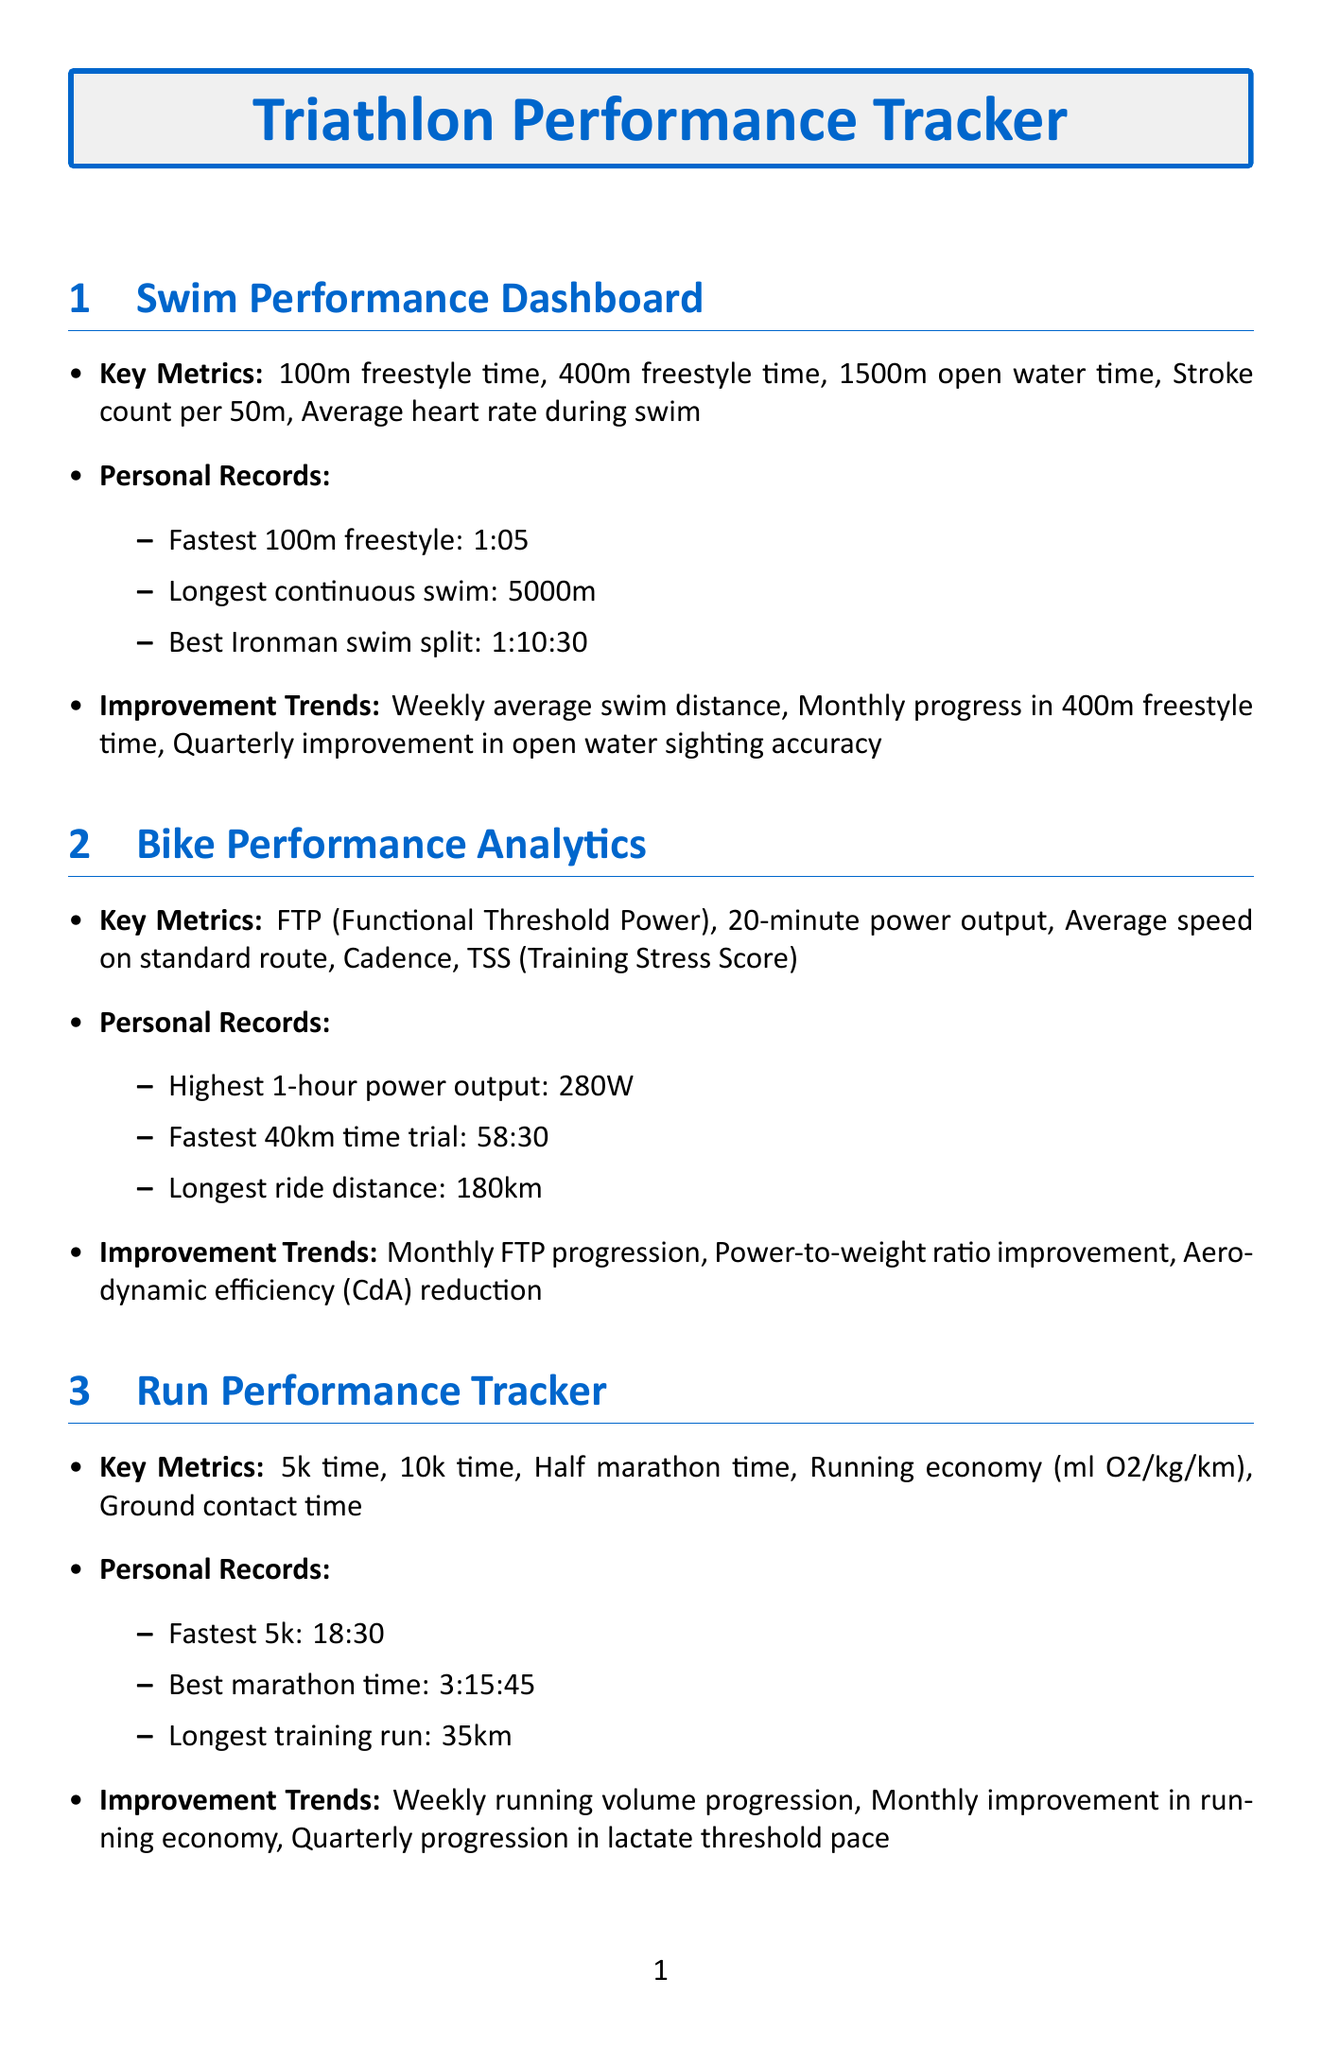what are the key metrics for swim performance? The document lists the swim performance metrics, including 100m freestyle time, 400m freestyle time, 1500m open water time, stroke count per 50m, and average heart rate during swim.
Answer: 100m freestyle time, 400m freestyle time, 1500m open water time, stroke count per 50m, average heart rate during swim what is the fastest 5k time? The personal records section for the run performance tracker states the fastest 5k time is 18:30.
Answer: 18:30 which device tracks heart rate monitoring? The document indicates the Garmin Forerunner 945 tracks heart rate monitoring among other metrics.
Answer: Garmin Forerunner 945 how often should long-term trend analysis be reviewed? According to the progress review frequency, long-term trend analysis should be reviewed quarterly.
Answer: Quarterly what is the best Ironman swim split recorded? The document notes the best Ironman swim split as 1:10:30 in the personal records for swim performance.
Answer: 1:10:30 which metric shows monthly FTP progression? The improvement trends for bike performance analytics include the metric for monthly FTP progression.
Answer: Monthly FTP progression what is the longest training run recorded? The personal records in the run performance tracker indicate the longest training run is 35km.
Answer: 35km what type of analysis does Strava provide? The document states that Strava offers segment performance tracking, social comparison, and training log visualization.
Answer: Segment performance tracking what is evaluated in the monthly review? The monthly review focuses on key performance indicators analysis, training block effectiveness evaluation, and nutrition plan adjustments.
Answer: Key performance indicators analysis, training block effectiveness evaluation, nutrition plan adjustments 